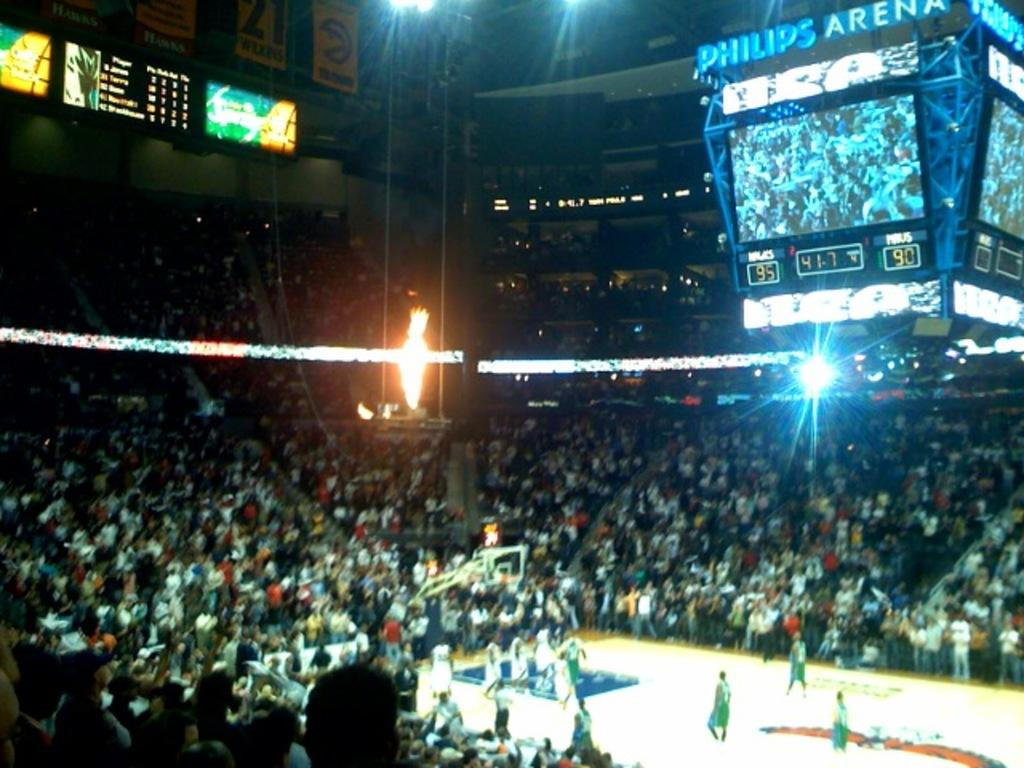<image>
Provide a brief description of the given image. A crowd of spectators enjoys the game at the Philips Arena. 